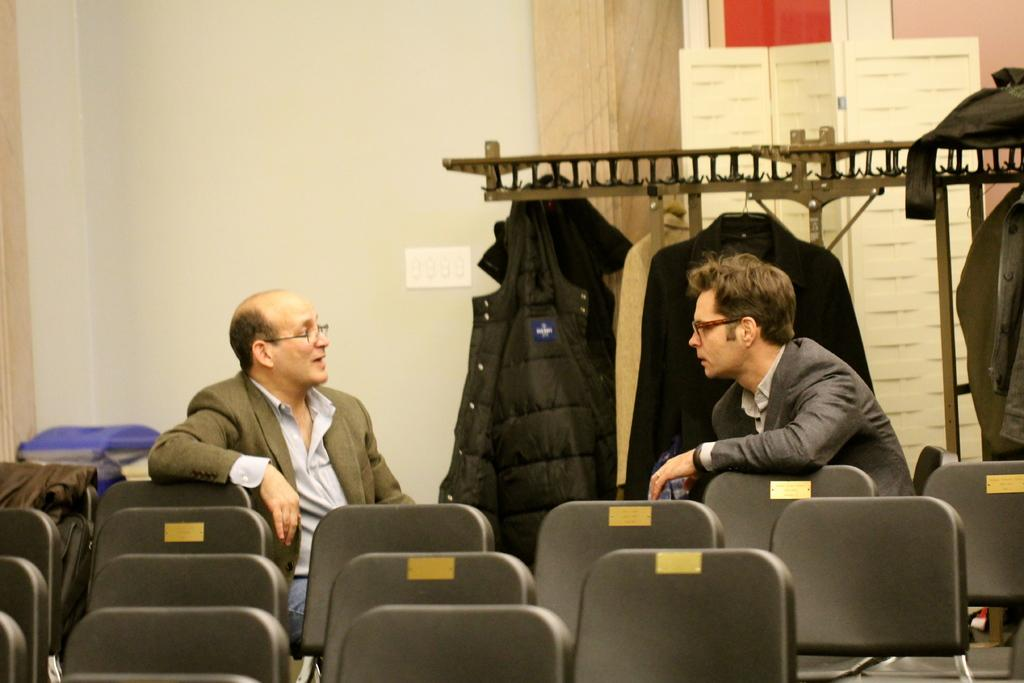What type of furniture is present in the room? There are chairs in the room. What are the people in the room doing? Two people are sitting and talking. What can be used to hang clothes in the room? There is a hanger in the room. What is hanging from the hanger? Clothes are hanging from the hanger. Can you see any rabbits playing in the stream in the image? There is no stream or rabbits present in the image. How many ducks are swimming in the clothes hanging from the hanger? There are no ducks present in the image, and the clothes are hanging from a hanger, not a body of water. 